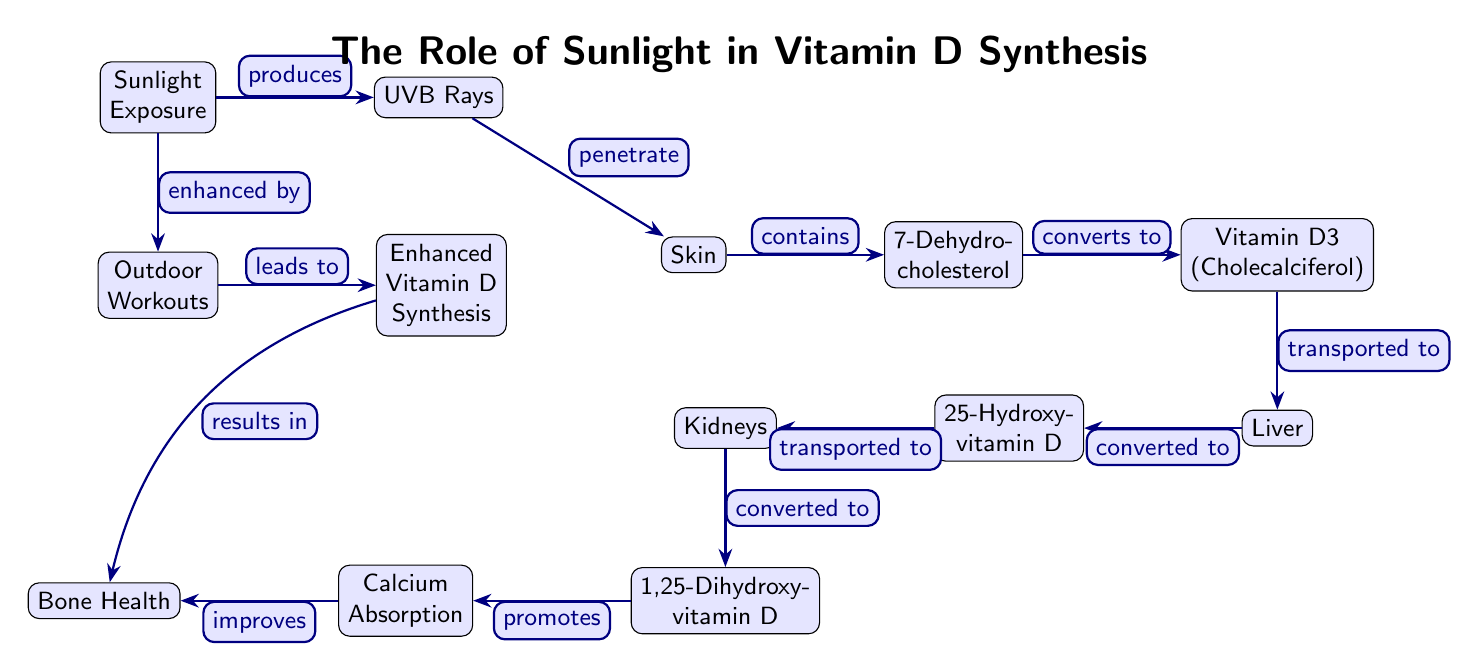What produces UVB rays? According to the diagram, sunlight exposure is indicated as the source that produces UVB rays.
Answer: Sunlight Exposure What does the skin contain? The diagram shows that the skin contains 7-Dehydro-cholesterol after UVB rays penetrate it.
Answer: 7-Dehydro-cholesterol How many total nodes are in the diagram? There are 12 distinct nodes presented in the diagram, including nodes for sunlight exposure, UVB rays, and other components involved in vitamin D synthesis.
Answer: 12 What is the final product that improves bone health? The diagram indicates that 1,25-Dihydroxy-vitamin D, which promotes calcium absorption, ultimately improves bone health.
Answer: 1,25-Dihydroxy-vitamin D What leads to enhanced vitamin D synthesis? The diagram illustrates that outdoor workouts lead to enhanced vitamin D synthesis by being enhanced by sunlight exposure.
Answer: Outdoor Workouts How is 25-Hydroxy-vitamin D transported? According to the diagram, 25-Hydroxy-vitamin D is shown as being transported to the kidneys after being converted in the liver.
Answer: Transported to Kidneys What promotes calcium absorption? The diagram indicates that 1,25-Dihydroxy-vitamin D promotes calcium absorption in the process connected to bone health.
Answer: 1,25-Dihydroxy-vitamin D What is the direct relationship between outdoor workouts and bone health? The diagram specifies that enhanced vitamin D synthesis from outdoor workouts ultimately results in improved bone health, showing a direct relationship.
Answer: Improved Bone Health 